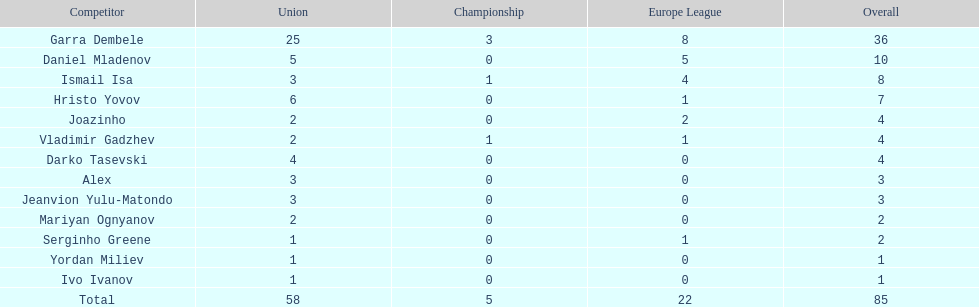Which players have at least 4 in the europa league? Garra Dembele, Daniel Mladenov, Ismail Isa. 